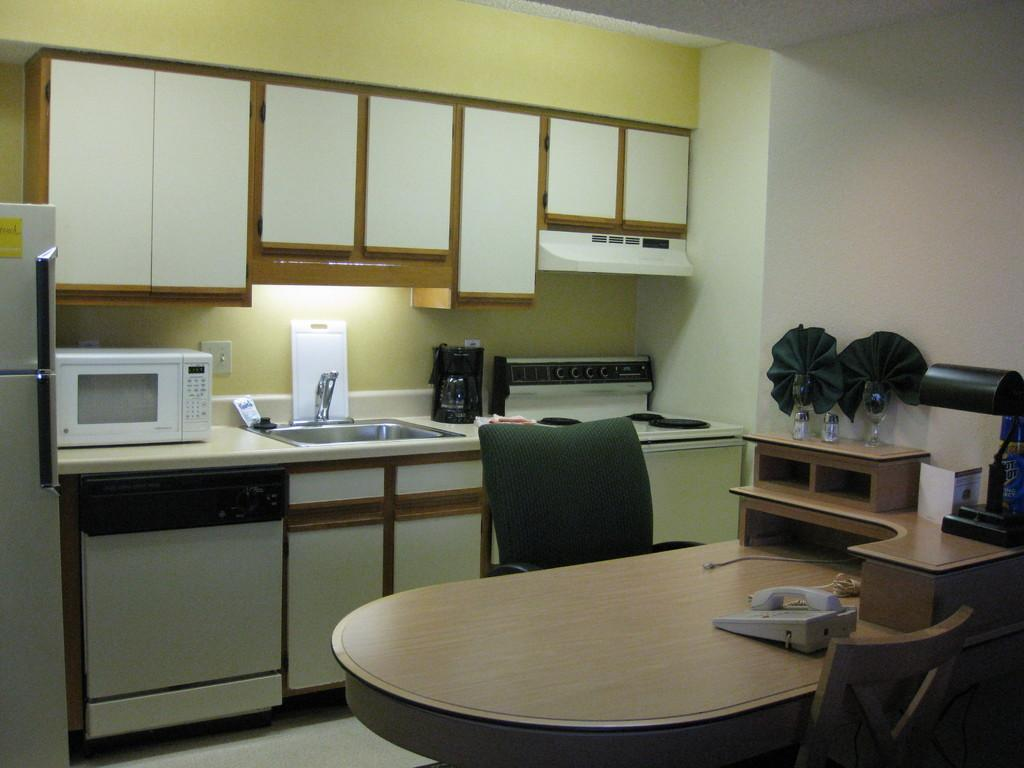What type of environment is shown in the image? The image depicts the interior of a room. What communication device can be seen in the room? There is a telephone in the room. What items are on the table in the room? There are bottles on a table in the room. What type of furniture is present in the room? There are chairs in the room. What gas appliance is in the room? There is a gas appliance in the room. What type of water fixture is in the room? There is a tap in the room. What cooking appliance is in the room? There is an oven in the room. What type of appliance is used for storing food in the room? There is a fridge in the room. What type of grass is growing on the floor in the image? There is no grass present in the image; it depicts the interior of a room with various appliances and furniture. 